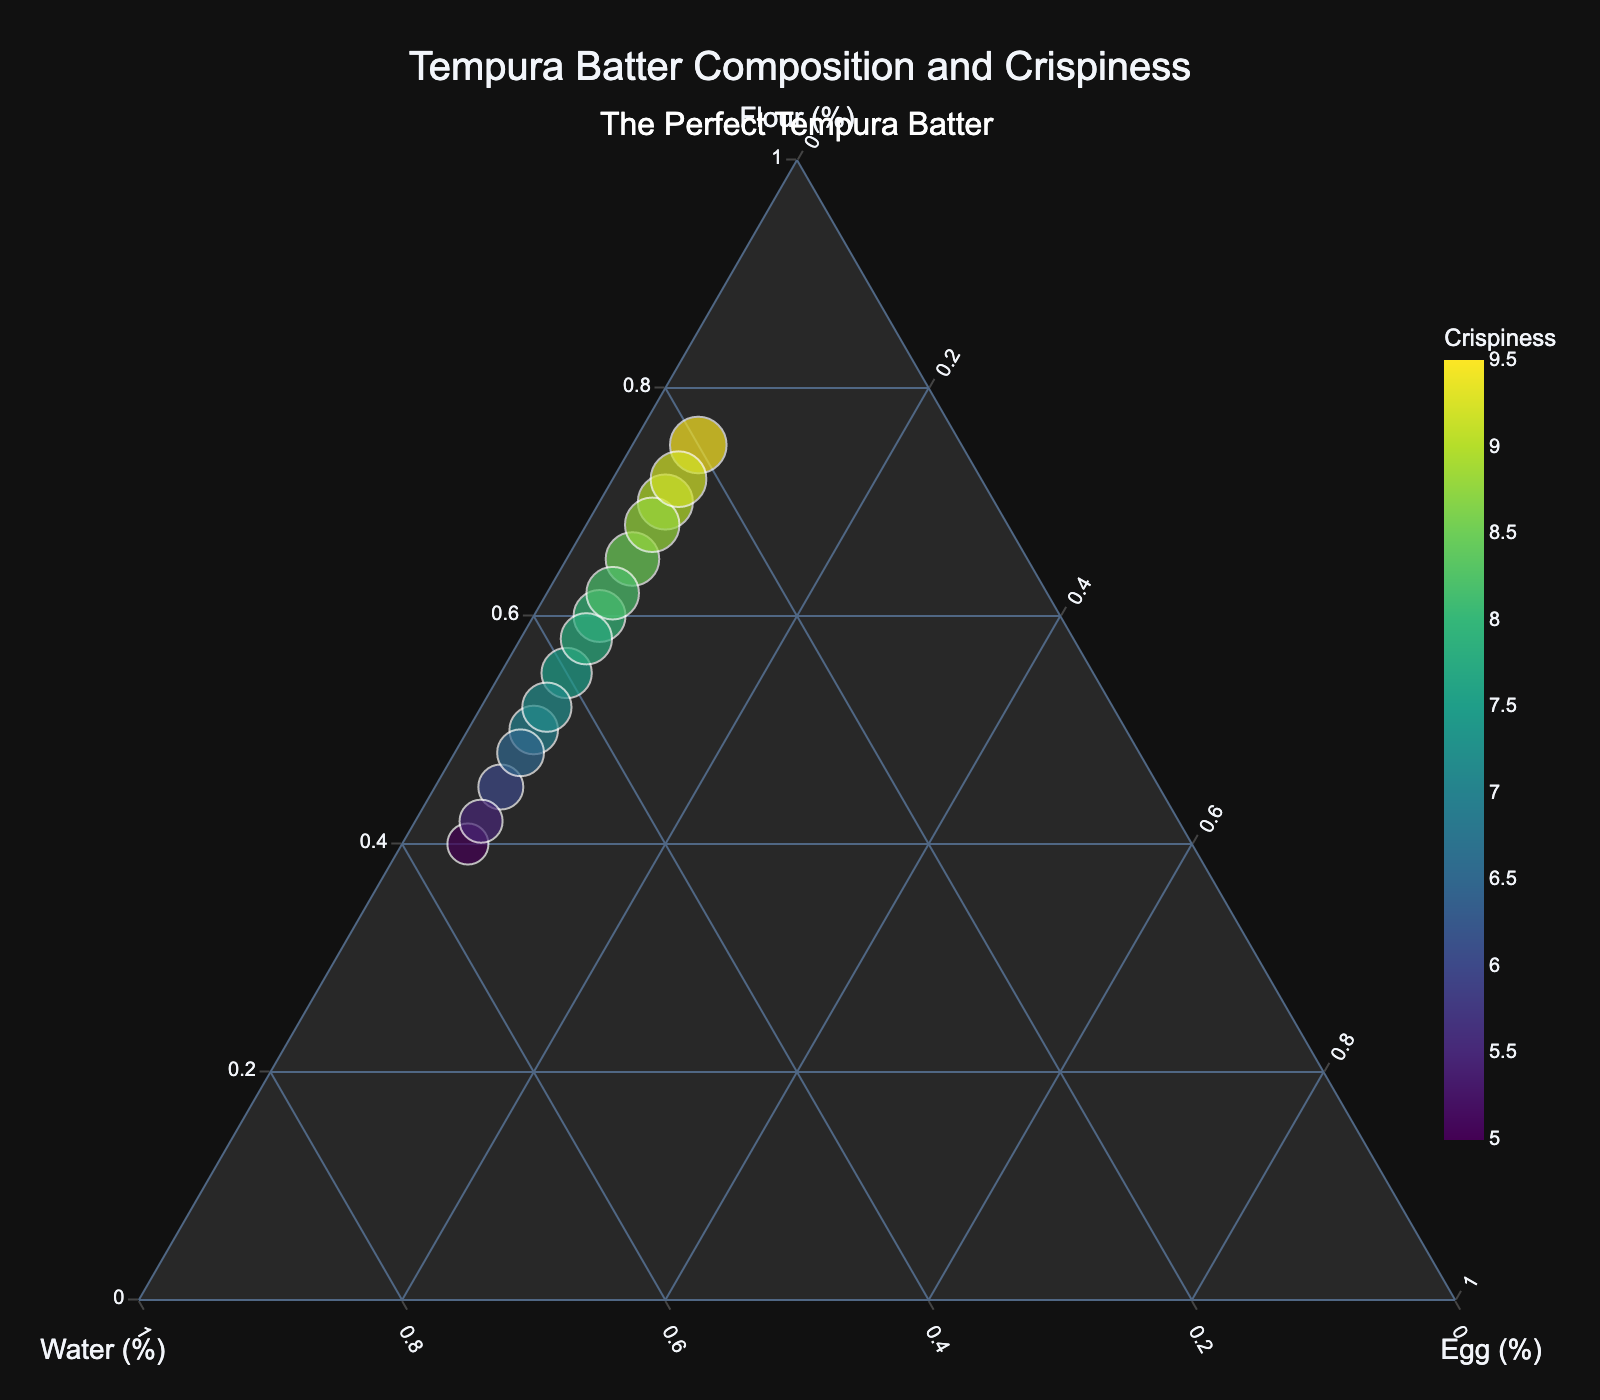How many ingredients are represented in the plot? The title "Tempura Batter Composition and Crispiness" hints at three ingredients, and the ternary plot naturally suggests three components. The axes confirm this with labels for Flour, Water, and Egg.
Answer: Three What is the crispiness score for a composition of 40% Flour, 55% Water, and 5% Egg? Locate the data point near 40% Flour, 55% Water, and 5% Egg. The hover information or size may show that this data point has a crispiness score of 5.
Answer: 5 Which ingredient appears to be kept constant at 5% in all compositions? By observing the ternary plot, you can see that the Egg percentage remains fixed at 5% for all data points.
Answer: Egg Where on the plot can the highest crispiness scores be found? The highest crispiness scores are represented by larger markers or deeper colors in the plot. These are found near the region with higher Flour percentages and lower Water percentages.
Answer: Near high Flour and low Water percentages What is the crispiness score for a composition of 75% Flour, 20% Water, and 5% Egg? Locate the data point around 75% Flour, 20% Water, and 5% Egg, and view its hover details or marker size which likely show a crispiness score of 9.5.
Answer: 9.5 What appears to be the trend between Flour content and crispiness? Observing the plot shows higher crispiness scores clustered around higher Flour percentages and lower Water percentages. This suggests an increasing trend in crispiness with higher Flour content.
Answer: Higher Flour, higher crispiness What is the range of crispiness scores for the plot data? The plot displays crispiness scores from the data points. The lowest appears to be around 5 while the highest is near 9.5.
Answer: 5 to 9.5 Are there clusters of data points, and if so, what do they signify? Clusters are visible where there are many data points together. They signify common ingredient ratios tested, giving insights on frequently tested compositions and their crispiness scores.
Answer: Yes, they signify commonly tested compositions Which has a higher impact on crispiness, Flour or Water? From the plot, high crispiness scores concentrate at higher Flour percentages while low scores occur at higher Water percentages. Thus, Flour shows a stronger positive impact on crispiness than Water.
Answer: Flour For a batter composition with 42% Flour, 53% Water, and 5% Egg, what is the crispiness score? Locate the data point around 42% Flour, 53% Water, and 5% Egg and note its crispiness score from hover details or marker size, which shows around 5.5.
Answer: 5.5 